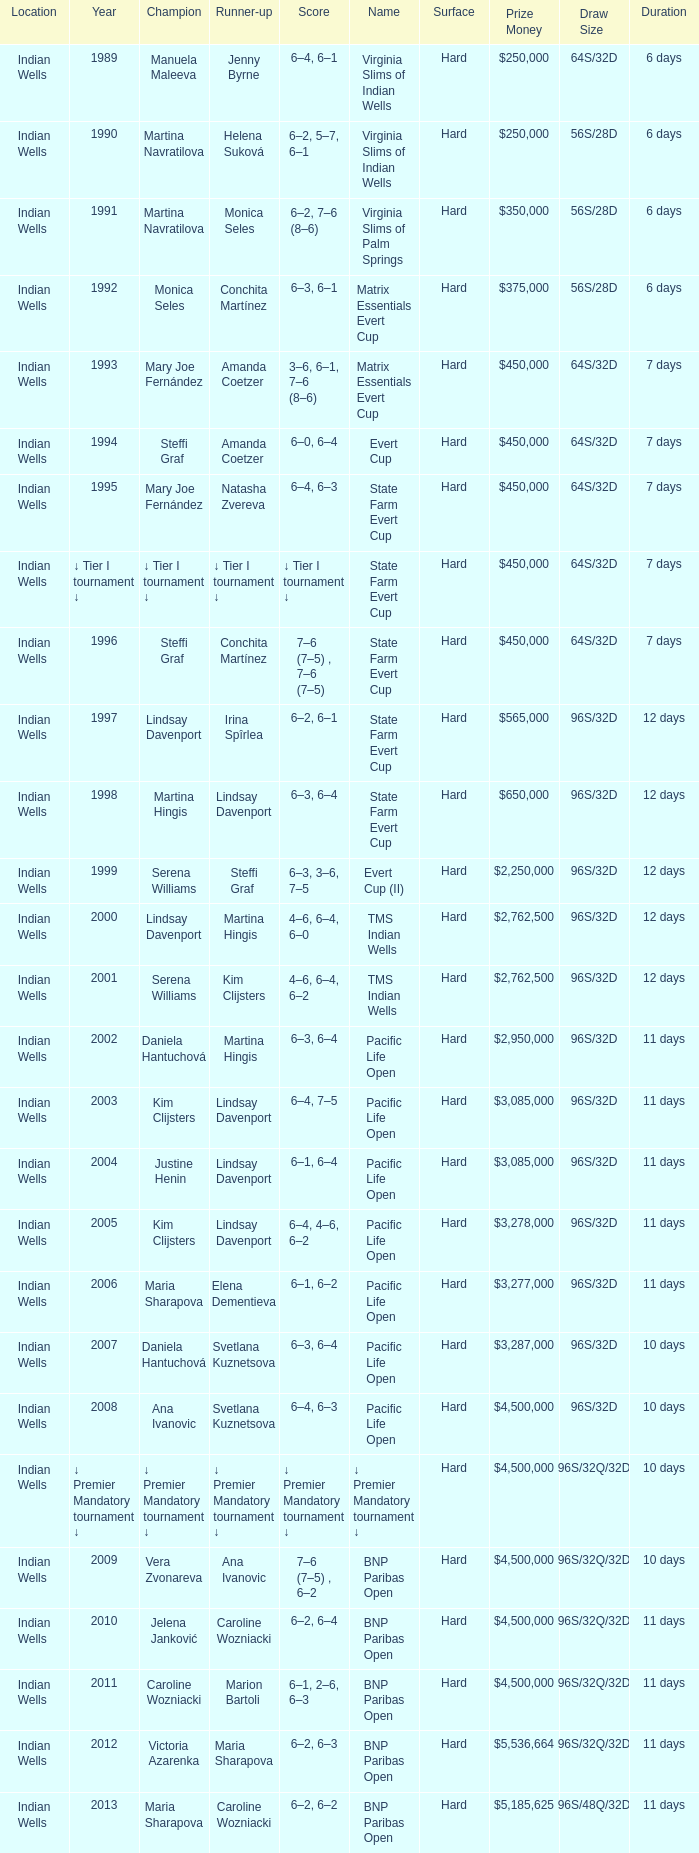Who was runner-up in the 2006 Pacific Life Open? Elena Dementieva. 